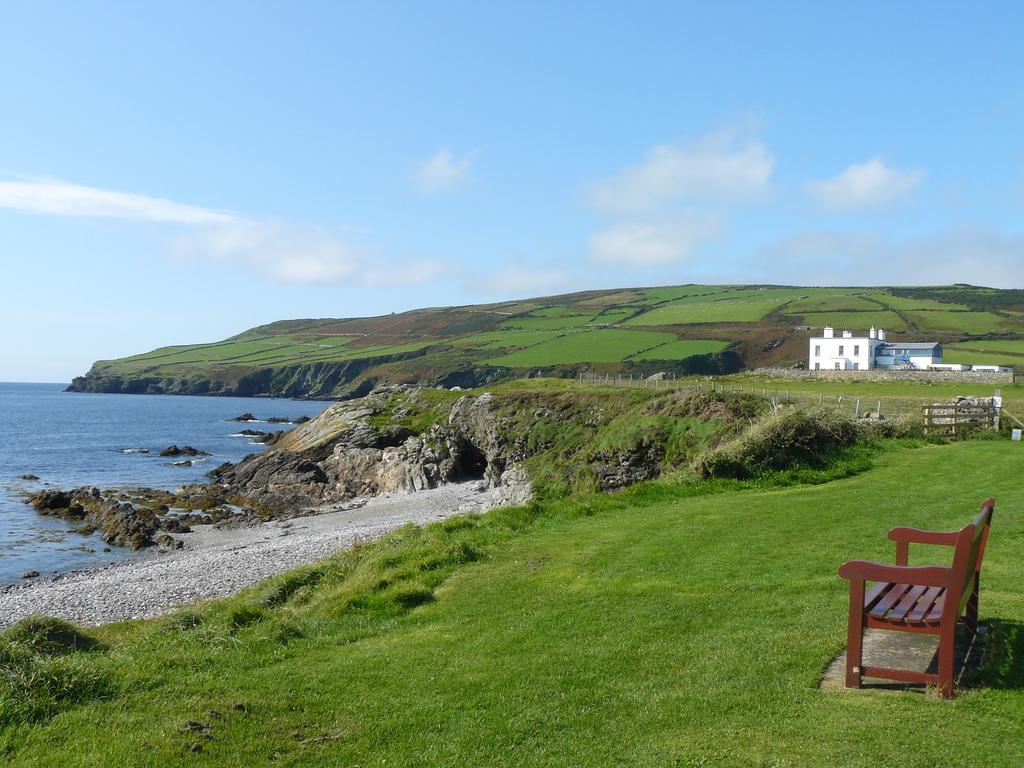Describe this image in one or two sentences. In this picture I can see a bench, there is a house, fence, grass, there is a hill, there is water, and in the background there is the sky. 